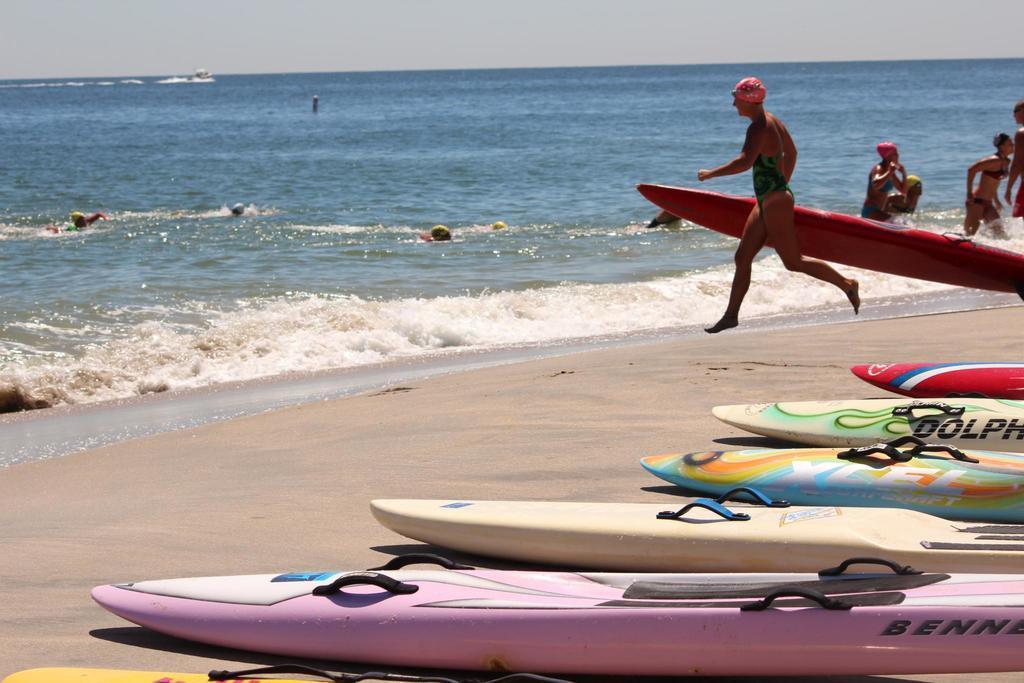<image>
Render a clear and concise summary of the photo. A Dolphin brand surf board sits among other surfboards on the beach. 